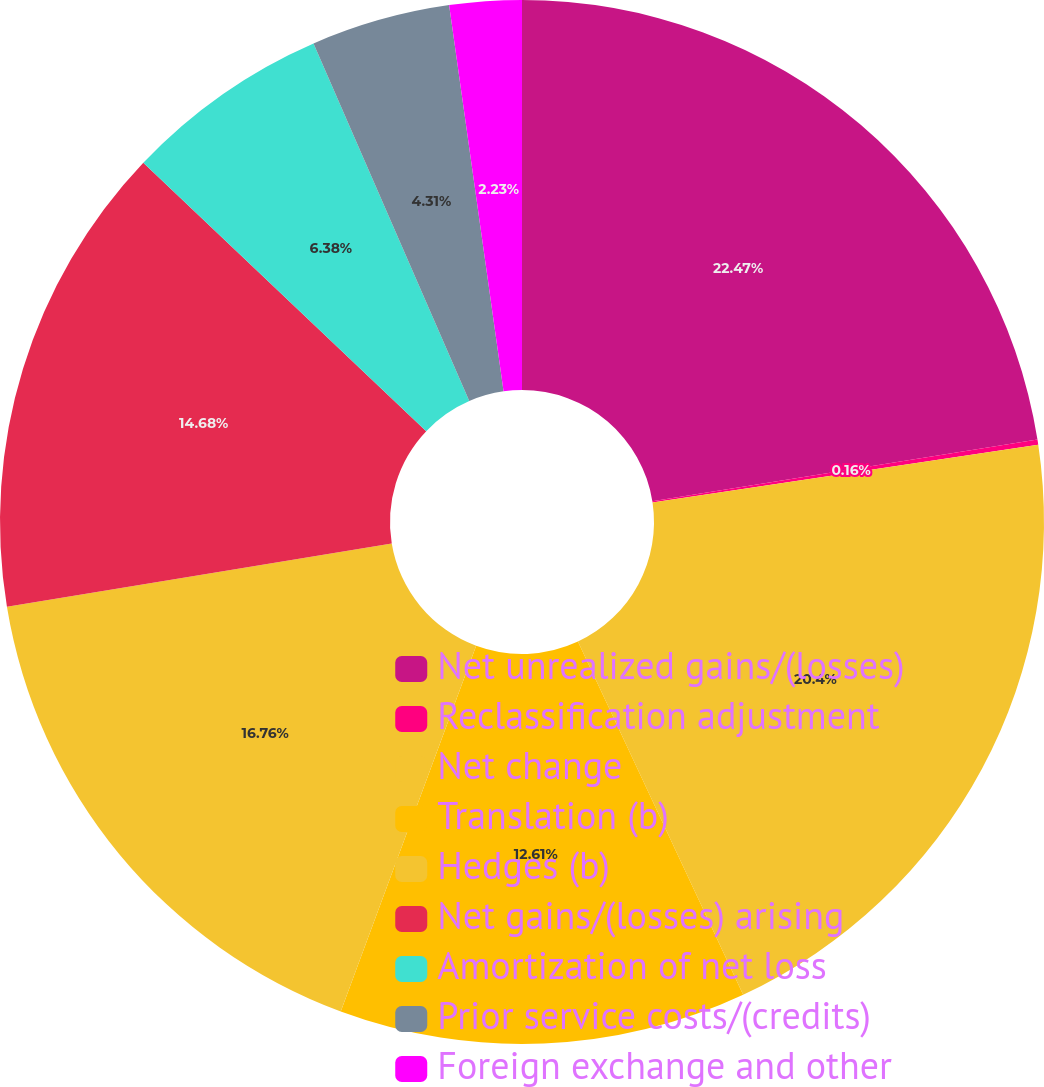Convert chart to OTSL. <chart><loc_0><loc_0><loc_500><loc_500><pie_chart><fcel>Net unrealized gains/(losses)<fcel>Reclassification adjustment<fcel>Net change<fcel>Translation (b)<fcel>Hedges (b)<fcel>Net gains/(losses) arising<fcel>Amortization of net loss<fcel>Prior service costs/(credits)<fcel>Foreign exchange and other<nl><fcel>22.48%<fcel>0.16%<fcel>20.4%<fcel>12.61%<fcel>16.76%<fcel>14.68%<fcel>6.38%<fcel>4.31%<fcel>2.23%<nl></chart> 